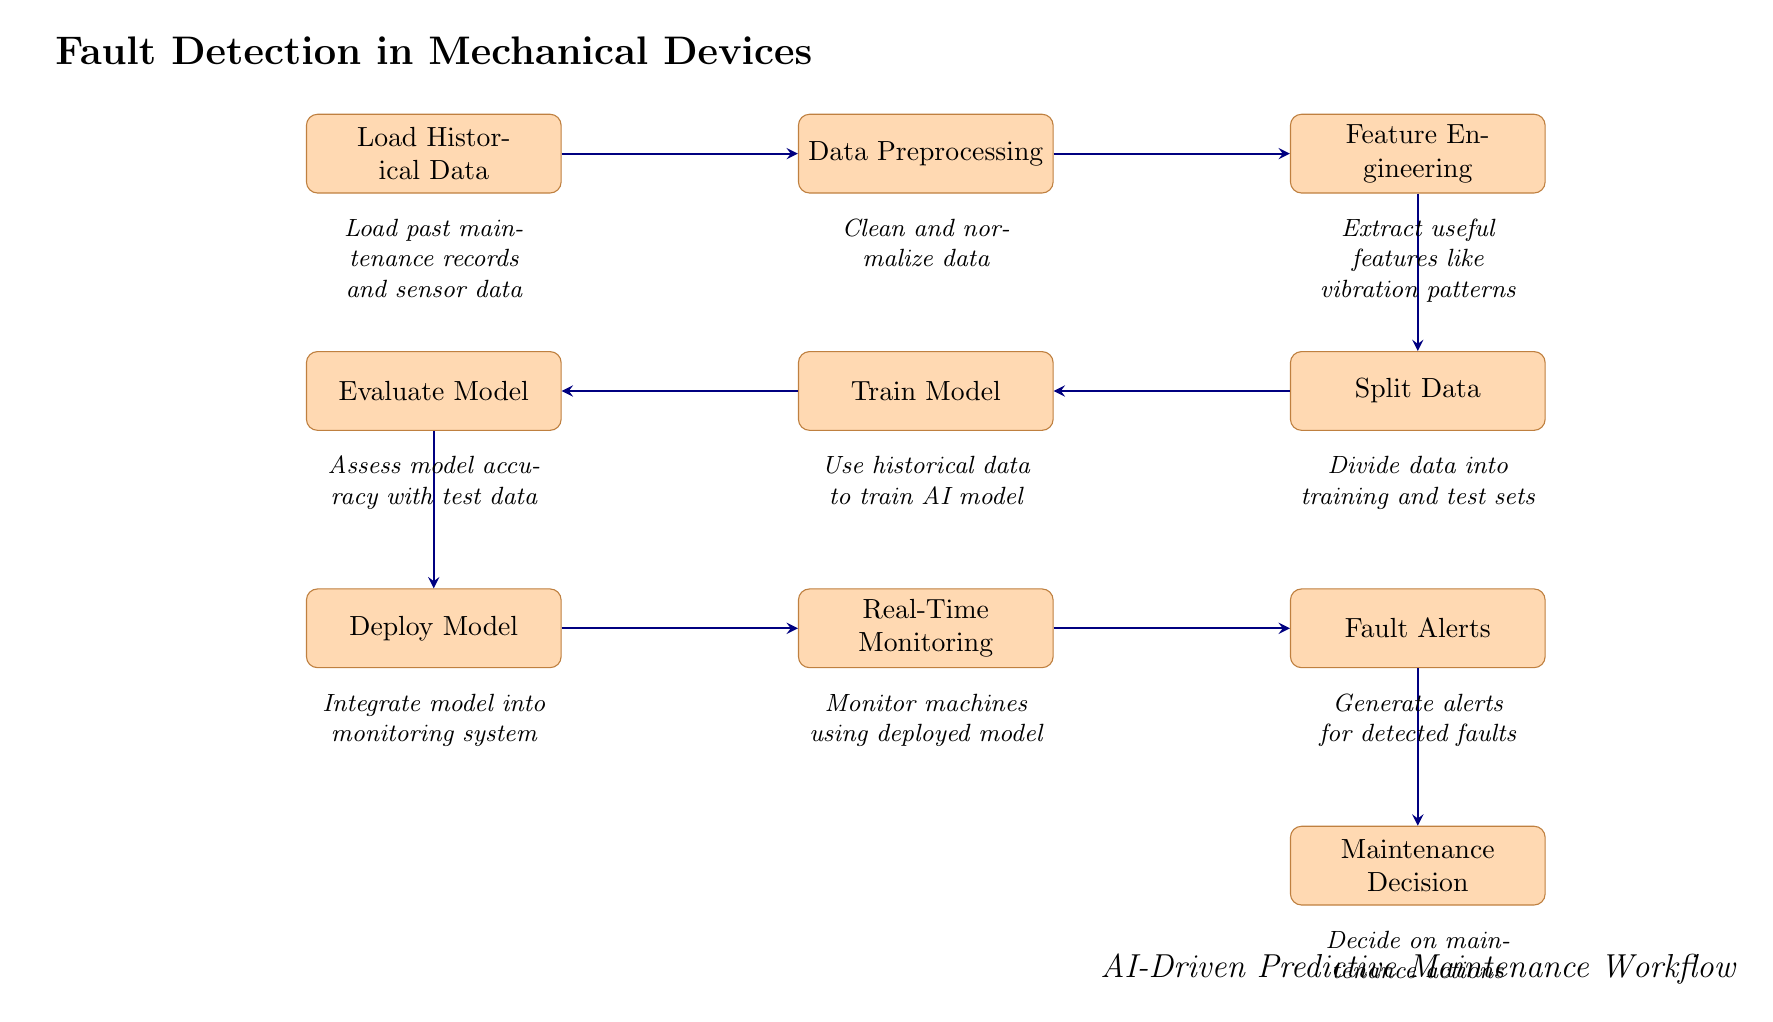What is the first step in the workflow? The first step in the diagram is labeled "Load Historical Data," and it is positioned at the top of the flow.
Answer: Load Historical Data How many main process nodes are in the diagram? By counting the distinct rectangle nodes representing processes, there are a total of 10 nodes.
Answer: 10 What follows after 'Evaluate Model'? The node that follows 'Evaluate Model' is 'Deploy Model,' indicating the next stage of the workflow.
Answer: Deploy Model Which node is responsible for generating alerts? The node responsible for generating alerts is 'Fault Alerts,' positioned to the right of 'Real-Time Monitoring.'
Answer: Fault Alerts What type of data is loaded in the first step? The first step specifies that past maintenance records and sensor data are loaded.
Answer: Past maintenance records and sensor data What is the last node in the sequence? The last node in the sequence, indicating the final outcome of the workflow, is 'Maintenance Decision.'
Answer: Maintenance Decision What process occurs between 'Train Model' and 'Deploy Model'? The process that occurs is 'Evaluate Model,' which assesses the accuracy of the trained model prior to deployment.
Answer: Evaluate Model In which stage are useful features extracted? Useful features are extracted during the 'Feature Engineering' stage, which follows data preprocessing.
Answer: Feature Engineering What is the purpose of the 'Real-Time Monitoring' node? The purpose of 'Real-Time Monitoring' is to monitor machines using the deployed model, ensuring ongoing oversight of device performance.
Answer: Monitor machines using deployed model 